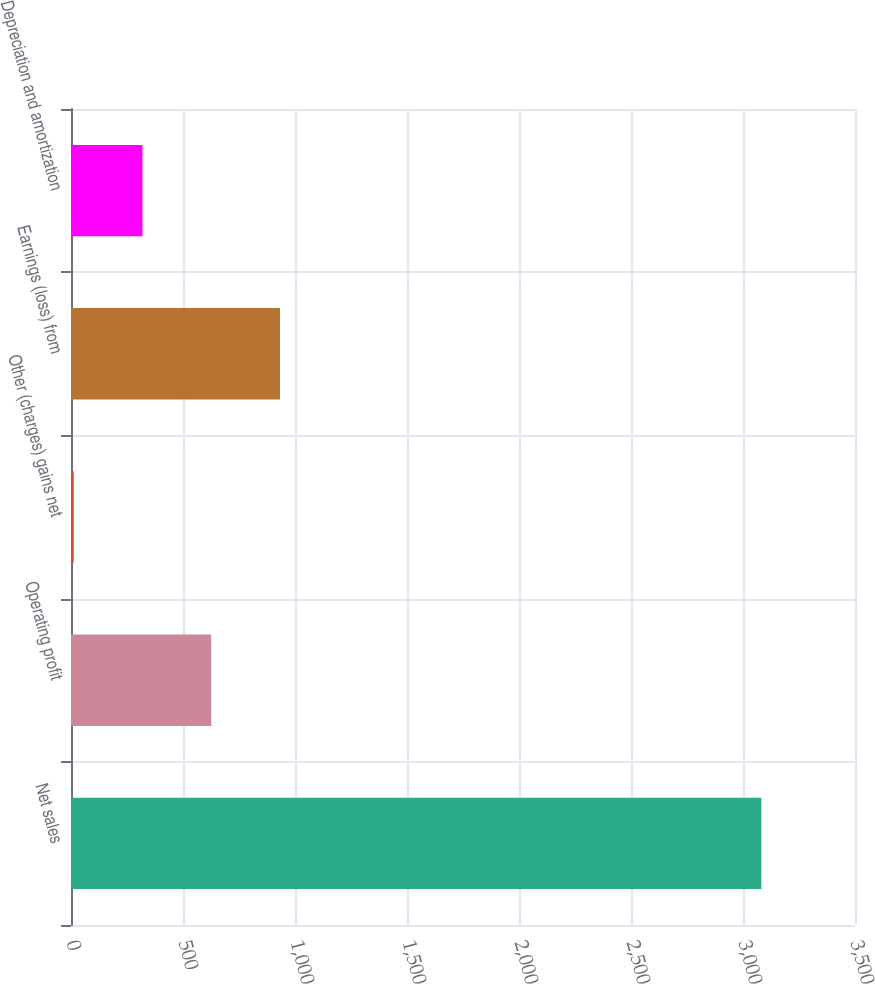<chart> <loc_0><loc_0><loc_500><loc_500><bar_chart><fcel>Net sales<fcel>Operating profit<fcel>Other (charges) gains net<fcel>Earnings (loss) from<fcel>Depreciation and amortization<nl><fcel>3082<fcel>626<fcel>12<fcel>933<fcel>319<nl></chart> 